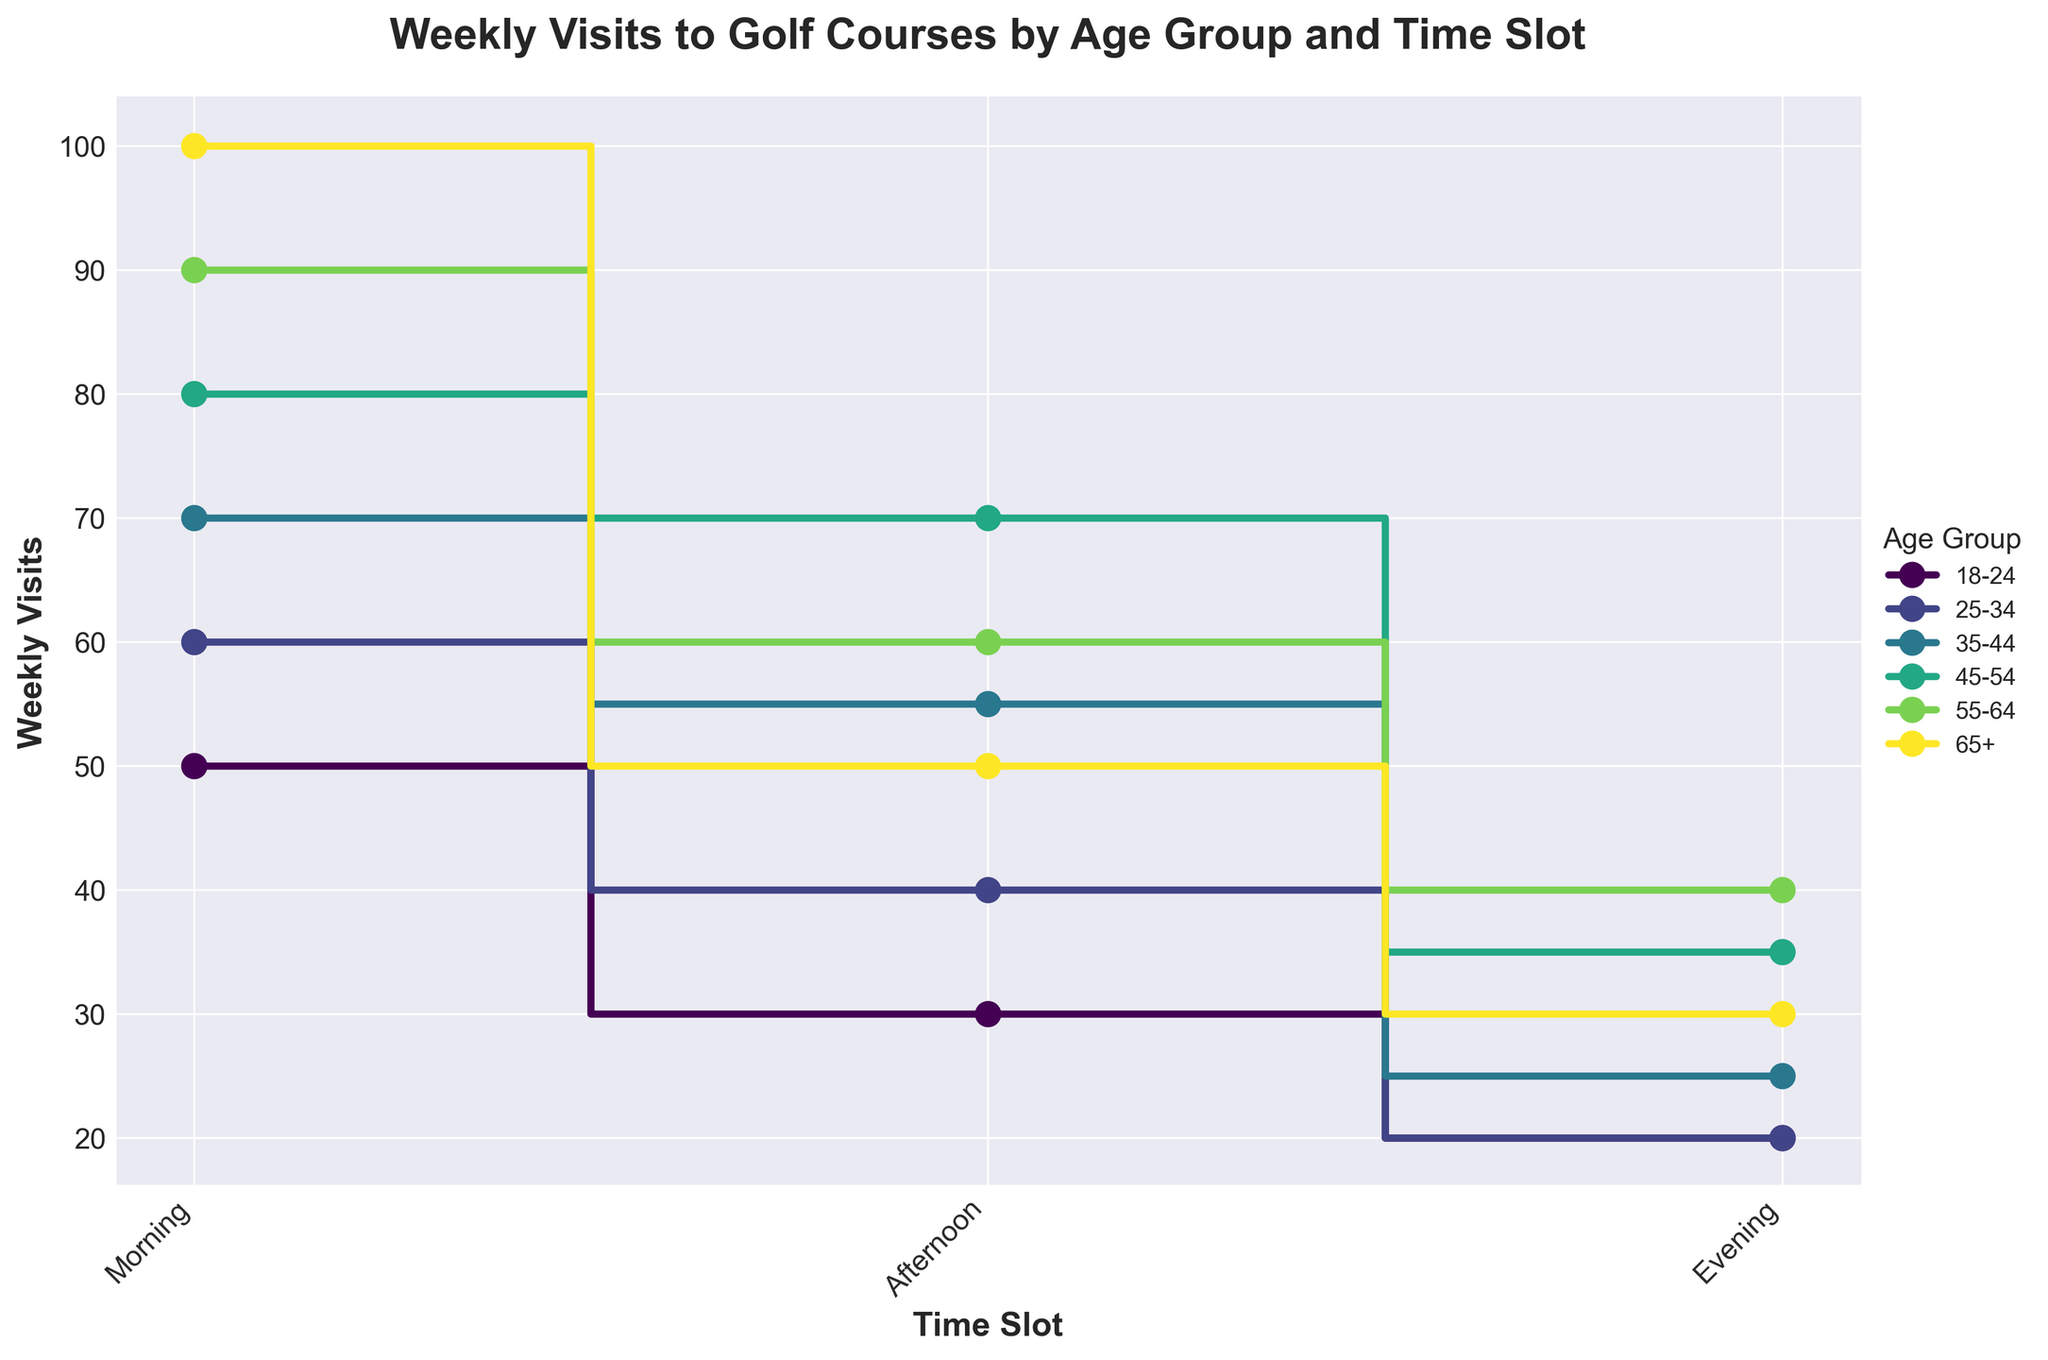What is the title of the plot? The title is located at the top of the plot, above the graph area. It is written in bold letters.
Answer: Weekly Visits to Golf Courses by Age Group and Time Slot How many unique age groups are represented in the plot? Each age group is represented by a distinct color with its label in the legend. Look at the legend on the right side of the plot to count the unique age groups.
Answer: 6 Which age group has the highest number of morning visits? Check the 'Morning' time slot for all age groups. Compare the values to find the highest. The corresponding label can be found in the legend.
Answer: 65+ How many people aged 45-54 visit in the afternoon compared to the evening? Locate the line for the 45-54 age group in both 'Afternoon' and 'Evening' slots. Read the values and subtract the evening visits from afternoon visits.
Answer: 35 What is the total number of weekly visits for all time slots by the 55-64 age group? Sum the visits in 'Morning', 'Afternoon', and 'Evening' for 55-64. The values are 90, 60, and 40 respectively.
Answer: 190 Which time slot is most popular for all age groups combined? Add the weekly visits for each time slot across all age groups and compare the totals. Morning: 450, Afternoon: 345, Evening: 170.
Answer: Morning Compare the morning visits between the 18-24 and 25-34 age groups. Which group visits more and by how much? Compare the visit numbers for 'Morning' in 18-24 and 25-34 age groups. Subtract the visits: 60 - 50.
Answer: 25-34 by 10 For the 35-44 age group, which time slot has the least number of visits and what is that number? Check the weekly visits for 35-44 in each time slot. Find and identify the smallest value.
Answer: Evening, 25 What trend can be observed in the morning visits as age increases? Compare the morning visit numbers across increasing age groups (18-24 to 65+). Identify any patterns.
Answer: Increases with age Which two age groups have the closest number of weekly visits in the evening? Compare the evening visit numbers for all age groups. Find two age groups with the smallest difference.
Answer: 18-24 and 65+ 